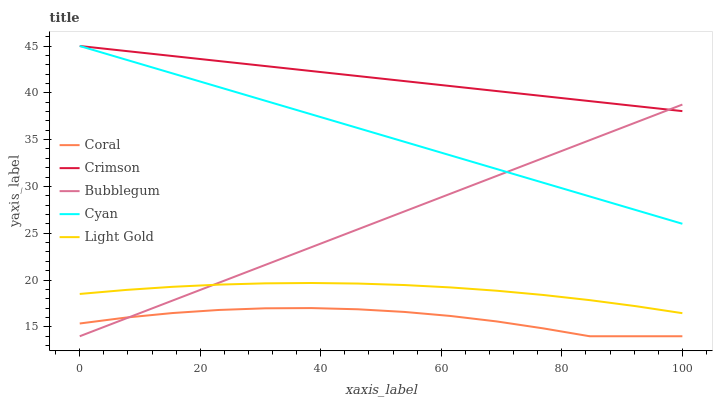Does Coral have the minimum area under the curve?
Answer yes or no. Yes. Does Crimson have the maximum area under the curve?
Answer yes or no. Yes. Does Cyan have the minimum area under the curve?
Answer yes or no. No. Does Cyan have the maximum area under the curve?
Answer yes or no. No. Is Bubblegum the smoothest?
Answer yes or no. Yes. Is Coral the roughest?
Answer yes or no. Yes. Is Cyan the smoothest?
Answer yes or no. No. Is Cyan the roughest?
Answer yes or no. No. Does Coral have the lowest value?
Answer yes or no. Yes. Does Cyan have the lowest value?
Answer yes or no. No. Does Cyan have the highest value?
Answer yes or no. Yes. Does Coral have the highest value?
Answer yes or no. No. Is Coral less than Light Gold?
Answer yes or no. Yes. Is Cyan greater than Coral?
Answer yes or no. Yes. Does Bubblegum intersect Coral?
Answer yes or no. Yes. Is Bubblegum less than Coral?
Answer yes or no. No. Is Bubblegum greater than Coral?
Answer yes or no. No. Does Coral intersect Light Gold?
Answer yes or no. No. 